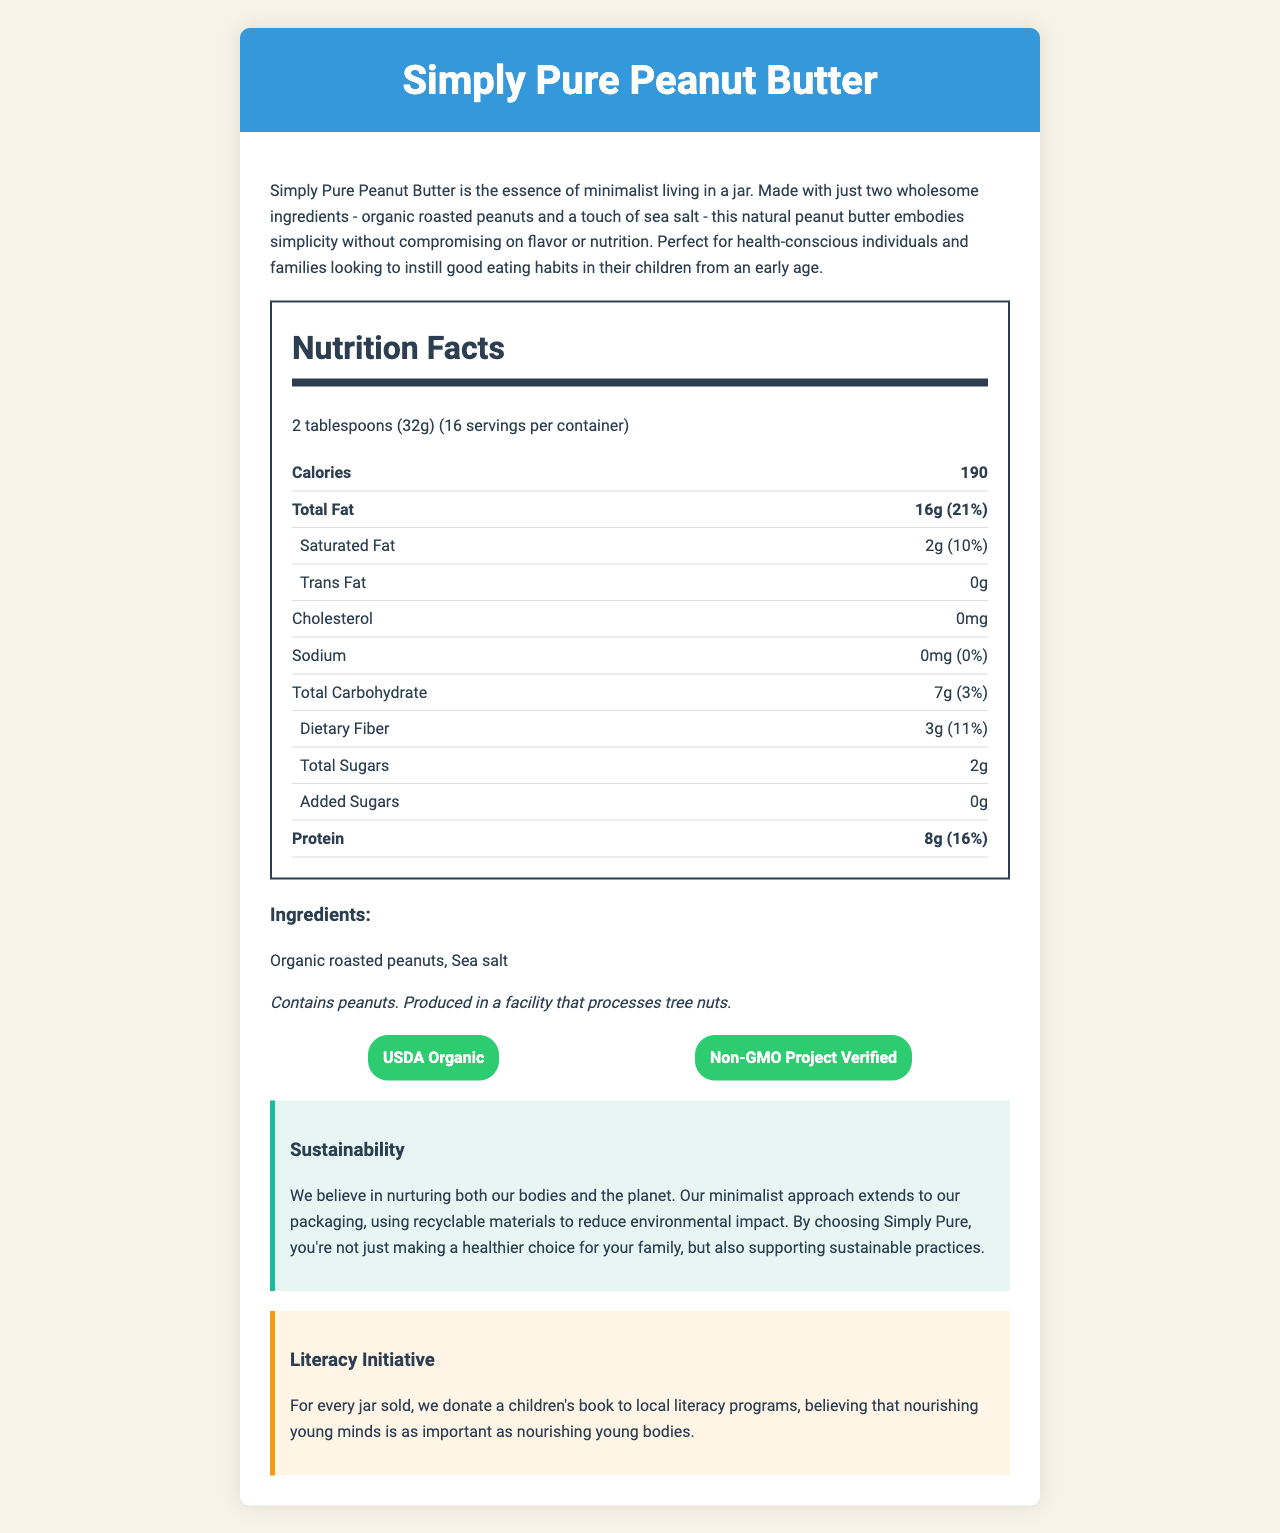what is the serving size of Simply Pure Peanut Butter? The serving size is stated as "2 tablespoons (32g)" in the nutrition facts section.
Answer: 2 tablespoons (32g) how many calories are in one serving? The nutrition facts label indicates that there are 190 calories per serving.
Answer: 190 what are the two ingredients in Simply Pure Peanut Butter? The ingredients list shows that Simply Pure Peanut Butter contains only organic roasted peanuts and sea salt.
Answer: Organic roasted peanuts, Sea salt how much protein does one serving contain? The nutrition facts section states that one serving contains 8 grams of protein.
Answer: 8g what is the daily value percentage of saturated fat per serving? The daily value percentage for saturated fat is listed as 10% in the nutrition facts.
Answer: 10% is there any added sugar in Simply Pure Peanut Butter? The nutrition facts explicitly state that there are 0 grams of added sugars.
Answer: No which certifications does Simply Pure Peanut Butter have? A. USDA Organic, Non-GMO Project Verified B. Gluten-Free, Kosher C. Fair Trade, Vegan The document lists "USDA Organic" and "Non-GMO Project Verified" as the certifications for Simply Pure Peanut Butter.
Answer: A. USDA Organic, Non-GMO Project Verified how much fiber is in one serving? A. 1g B. 2g C. 3g The nutrition facts section indicates that there are 3 grams of dietary fiber per serving.
Answer: C. 3g is Simply Pure Peanut Butter safe for people with peanut allergies? Yes/No The allergen information states that the product contains peanuts.
Answer: No what should be done with the peanut butter after opening the jar? The storage instructions advise to refrigerate the peanut butter after opening and to stir before use.
Answer: Refrigerate after opening. Stir before use. summarize the main idea of the document. The peanut butter is described as a product that emphasizes simplicity and health, with a focus on organic and non-GMO ingredients. The document also highlights the brand's commitment to environmental sustainability and literacy initiatives.
Answer: Simply Pure Peanut Butter is an all-natural, minimalist product made from just two ingredients (organic roasted peanuts and sea salt). It is rich in nutrients and free from added sugars. The product supports sustainability with its recyclable packaging and also promotes literacy by donating a children's book for every jar sold. what is the amount of sodium per serving in Simply Pure Peanut Butter? The nutrition facts label shows that the amount of sodium per serving is 0 milligrams.
Answer: 0mg can the document provide information about the price of Simply Pure Peanut Butter? The document does not contain any details regarding the price of Simply Pure Peanut Butter.
Answer: Not enough information 